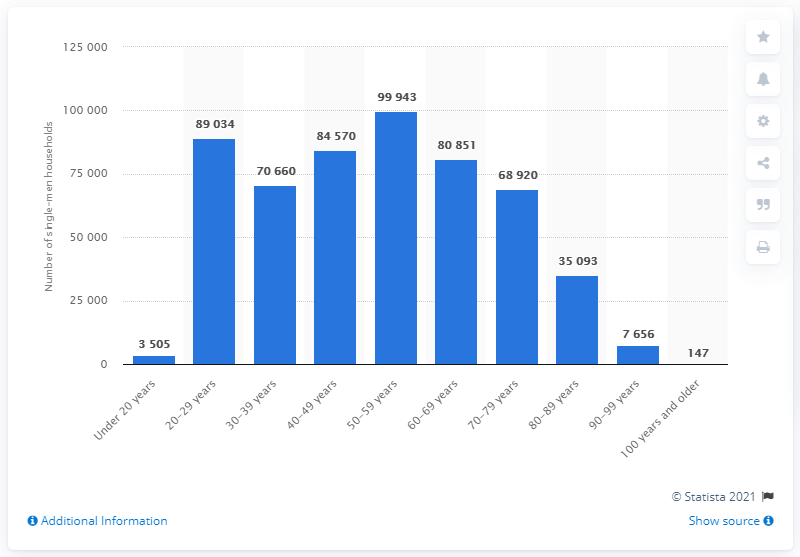Identify some key points in this picture. There were approximately 99,943 households in Denmark in 2021. 